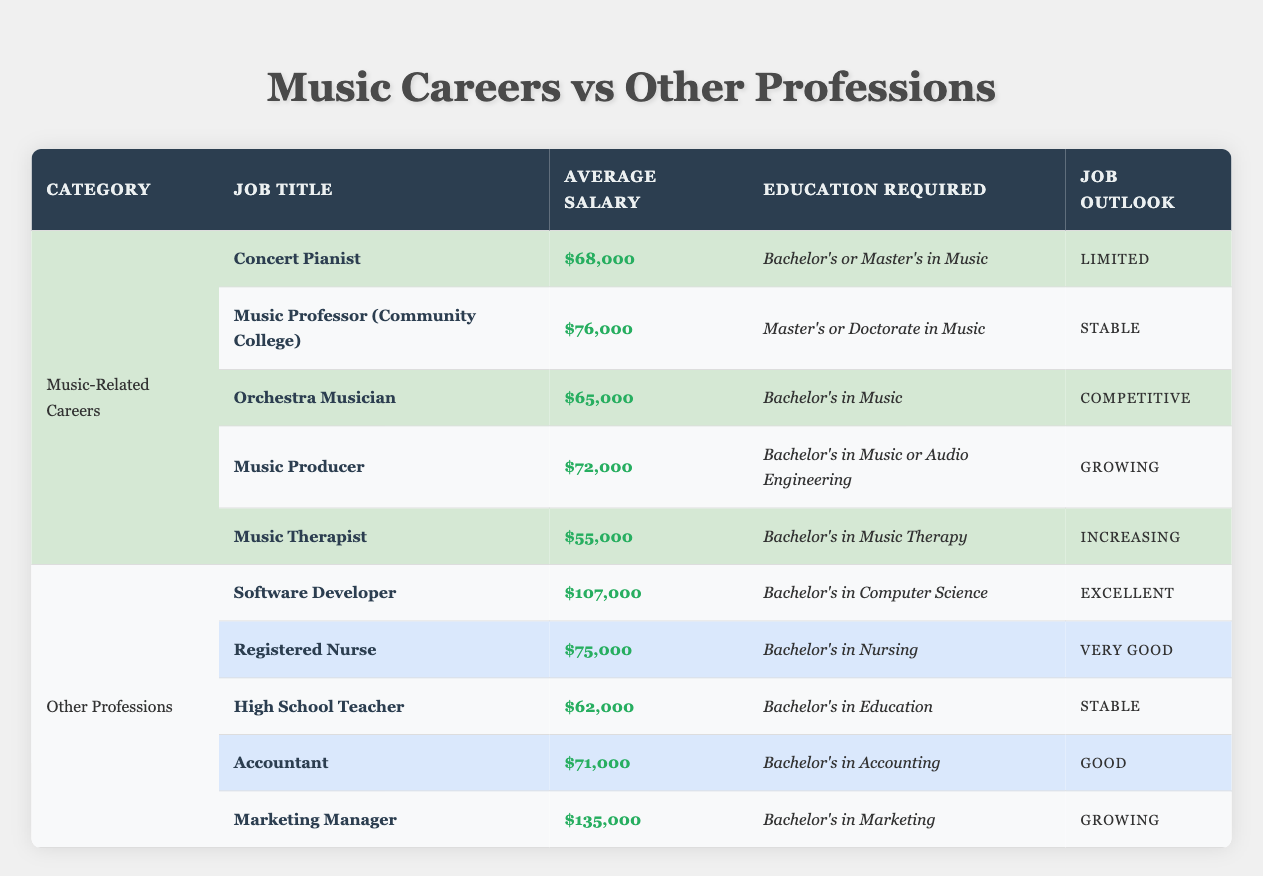What is the average salary of a Music Therapist? The average salary for a Music Therapist, as listed in the table, is $55,000. This is found directly in the row corresponding to the Music Therapist under the Music-Related Careers category.
Answer: $55,000 Which music-related career has the highest average salary? From the table, the music-related career with the highest average salary is the Music Professor (Community College), earning $76,000. This is determined by comparing the average salaries for all music-related careers listed.
Answer: Music Professor (Community College) How much more does a Software Developer earn compared to an Orchestra Musician? To find the difference in earnings, subtract the average salary of the Orchestra Musician ($65,000) from that of the Software Developer ($107,000). The calculation is $107,000 - $65,000 = $42,000.
Answer: $42,000 Is the average salary for a Music Producer higher than that of a Registered Nurse? According to the table, the average salary for a Music Producer is $72,000 and for a Registered Nurse is $75,000. Since $72,000 is less than $75,000, the answer is no, the average salary for a Music Producer is not higher.
Answer: No What is the combined average salary of all music-related careers listed? To find the combined average salary, first, add up the average salaries for all music-related careers: $68,000 + $76,000 + $65,000 + $72,000 + $55,000 = $336,000. There are 5 careers, so divide the total by 5 to get the average: $336,000 / 5 = $67,200.
Answer: $67,200 How many music-related careers have a stable job outlook? Looking at the table, two music-related careers have a stable job outlook: Music Professor (Community College) and Music Producer. Therefore, the answer is counted directly from the job outlooks listed.
Answer: 2 Which profession has the best job outlook, and what is that outlook? The profession with the best job outlook is Software Developer, which has an outlook classified as Excellent. This is identified by reading the job outlooks next to each profession in the table.
Answer: Excellent Is the average salary of a High School Teacher higher or lower than a Music Therapist? A High School Teacher earns $62,000 while a Music Therapist earns $55,000. Since $62,000 is greater than $55,000, the answer is that the average salary of a High School Teacher is higher.
Answer: Higher 